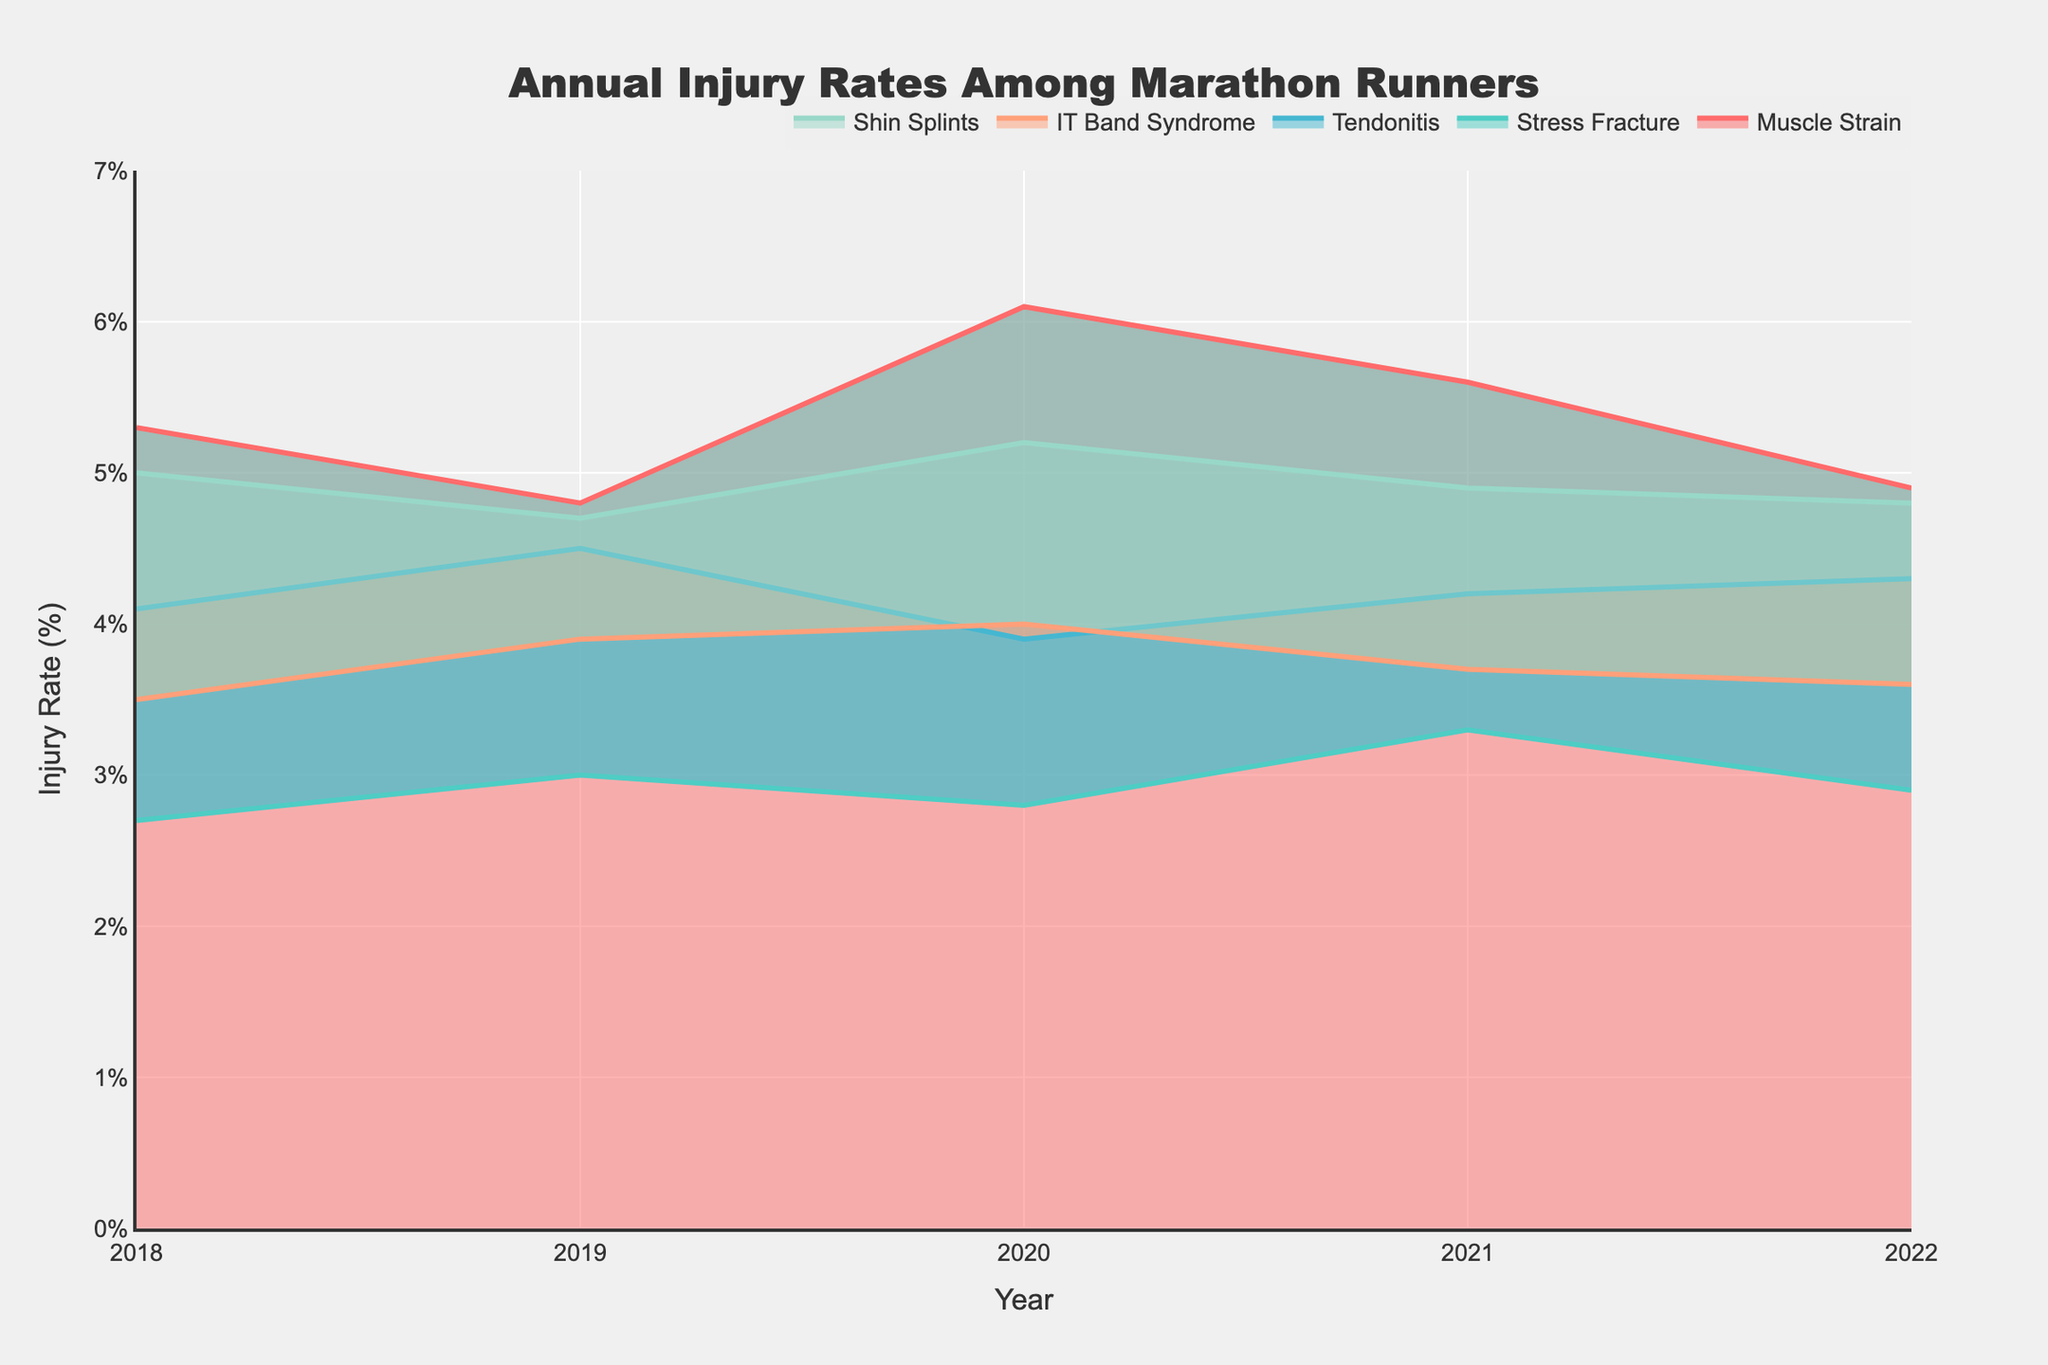What is the title of the chart? The title is located at the top center of the chart and it reads "Annual Injury Rates Among Marathon Runners".
Answer: Annual Injury Rates Among Marathon Runners Which injury had the highest rate in 2020? By looking at the 2020 data points on the chart, the injury with the highest rate is Muscle Strain with a rate of 6.1%.
Answer: Muscle Strain Between which years did the injury rate for Stress Fracture increase? The injury rate for Stress Fracture increased between the years 2018 and 2019, and again between 2020 and 2021. This can be observed by noting the upward trend in the line corresponding to Stress Fracture during these periods.
Answer: 2018-2019, 2020-2021 What is the overall trend of Shin Splints from 2018 to 2022? Observing the values from 2018 to 2022, Shin Splints shows a slight decrease from 5.0% to 4.8%, suggesting a slight overall declining trend despite minor fluctuations.
Answer: Slightly decreasing Which injury rate shows the biggest fluctuation over the years? By comparing the data points for each injury type, Muscle Strain shows the biggest fluctuation with rates ranging from 4.8% to 6.1%.
Answer: Muscle Strain How many types of injuries are tracked in the chart? The legend under the chart shows five distinct injury types: Muscle Strain, Stress Fracture, Tendonitis, IT Band Syndrome, and Shin Splints.
Answer: 5 In which year did the injury rate for IT Band Syndrome peak? The highest point on the IT Band Syndrome plot line is in 2020, where the rate peaked at 4.0%.
Answer: 2020 Comparing 2019 and 2022, which injury saw the largest decrease in injury rate? By comparing the rates for each injury between these two years, Muscle Strain had the largest decrease, dropping from 4.8% to 4.9%, a decrease of 0.7%.
Answer: Muscle Strain What is the average injury rate for Tendonitis over the years 2018 to 2022? The injury rates for Tendonitis from 2018 to 2022 are 4.1, 4.5, 3.9, 4.2, and 4.3 respectively. Summing these values and dividing by 5 gives an average rate of (4.1+4.5+3.9+4.2+4.3)/5 = 4.2%.
Answer: 4.2% How does the injury rate for Muscle Strain in 2018 compare with its rate in 2022? Observing the rate for Muscle Strain, it was 5.3% in 2018 and 4.9% in 2022, showing a decrease.
Answer: Decrease 